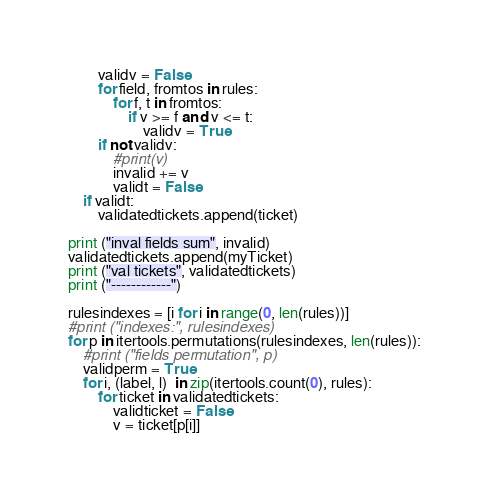<code> <loc_0><loc_0><loc_500><loc_500><_Python_>        validv = False
        for field, fromtos in rules:
            for f, t in fromtos:
                if v >= f and v <= t:
                    validv = True
        if not validv:
            #print(v)
            invalid += v
            validt = False
    if validt:
        validatedtickets.append(ticket)

print ("inval fields sum", invalid)
validatedtickets.append(myTicket)
print ("val tickets", validatedtickets)
print ("------------")

rulesindexes = [i for i in range(0, len(rules))]
#print ("indexes:", rulesindexes)
for p in itertools.permutations(rulesindexes, len(rules)):
    #print ("fields permutation", p)
    validperm = True
    for i, (label, l)  in zip(itertools.count(0), rules):
        for ticket in validatedtickets:
            validticket = False
            v = ticket[p[i]]</code> 